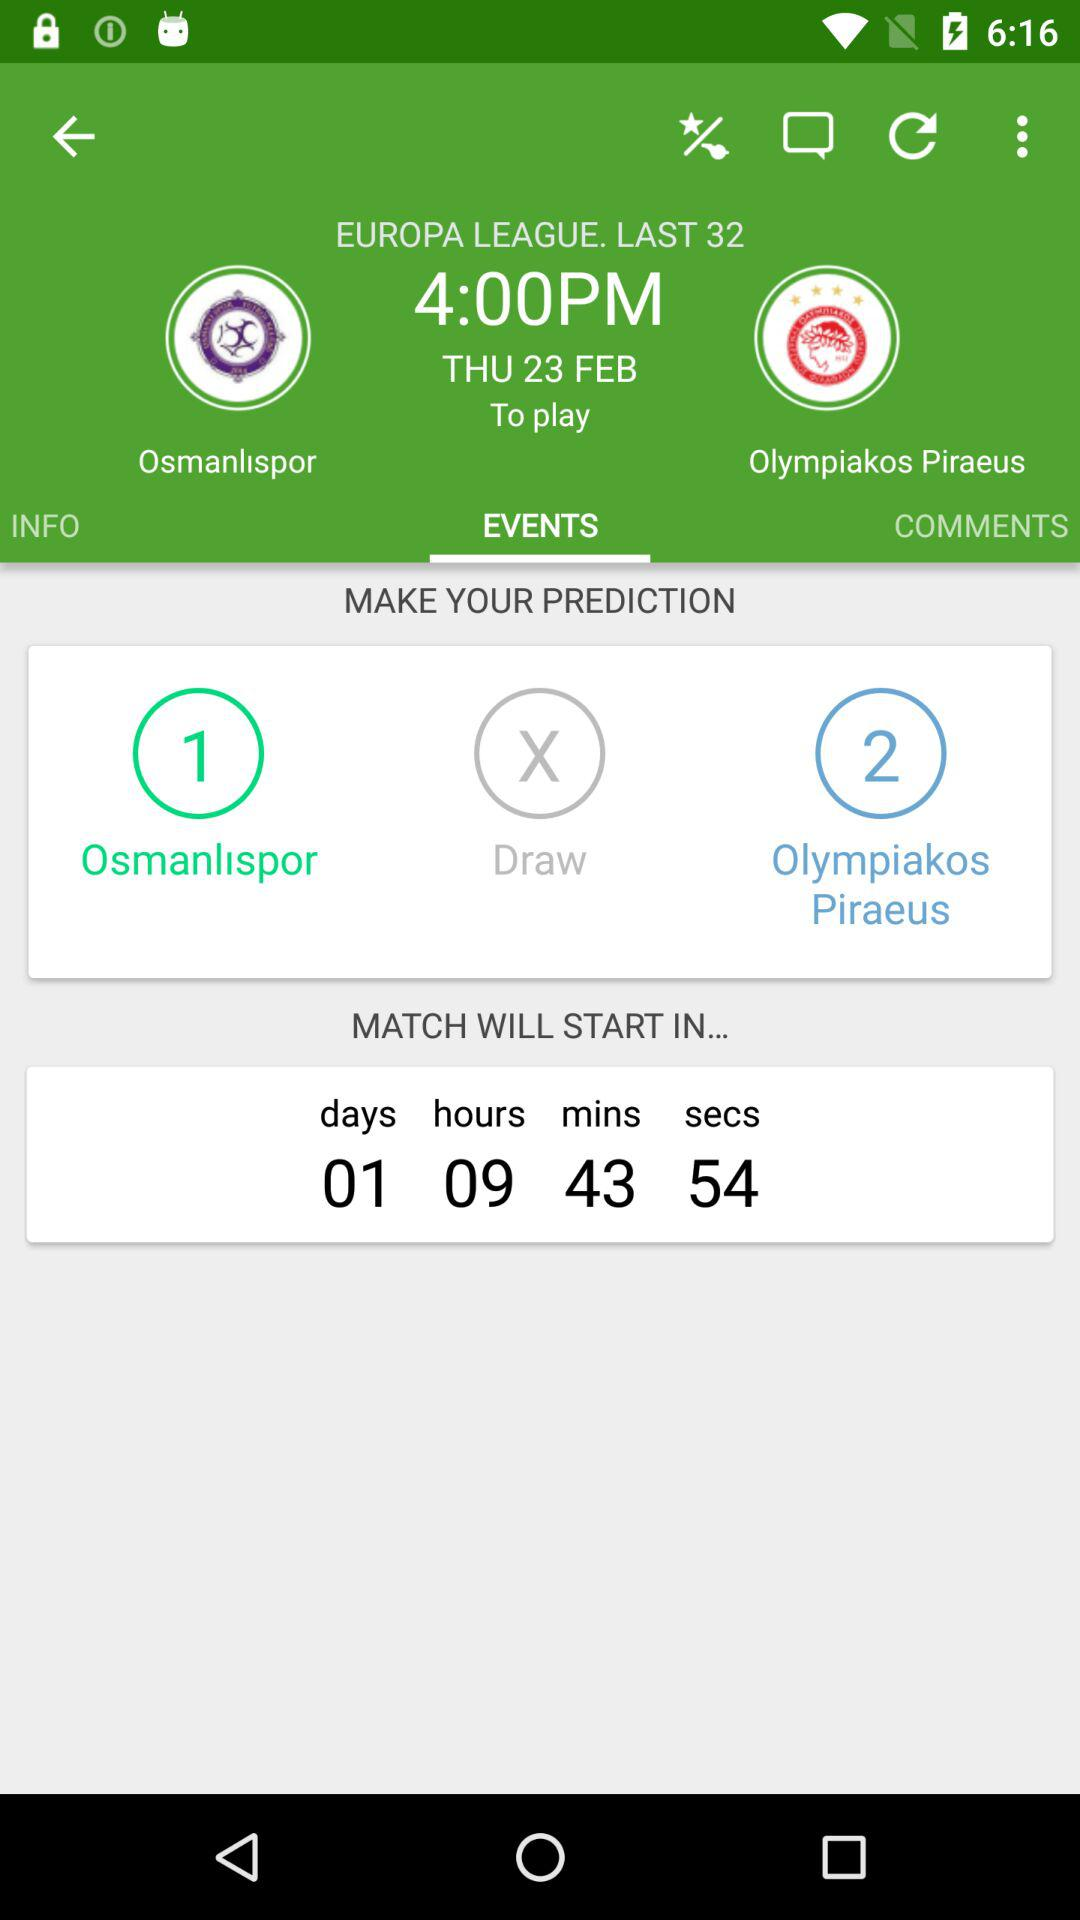What is the date of the match? The date is Thursday, February 23. 